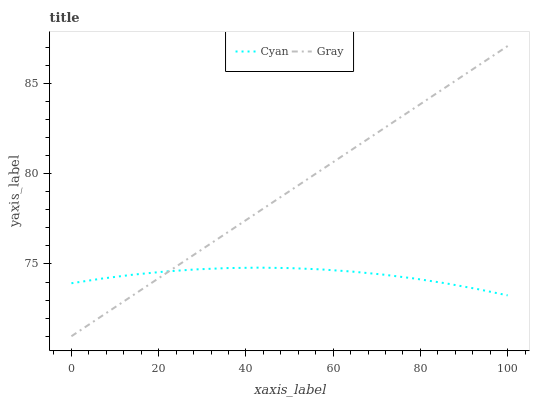Does Cyan have the minimum area under the curve?
Answer yes or no. Yes. Does Gray have the maximum area under the curve?
Answer yes or no. Yes. Does Gray have the minimum area under the curve?
Answer yes or no. No. Is Gray the smoothest?
Answer yes or no. Yes. Is Cyan the roughest?
Answer yes or no. Yes. Is Gray the roughest?
Answer yes or no. No. Does Gray have the lowest value?
Answer yes or no. Yes. Does Gray have the highest value?
Answer yes or no. Yes. Does Cyan intersect Gray?
Answer yes or no. Yes. Is Cyan less than Gray?
Answer yes or no. No. Is Cyan greater than Gray?
Answer yes or no. No. 